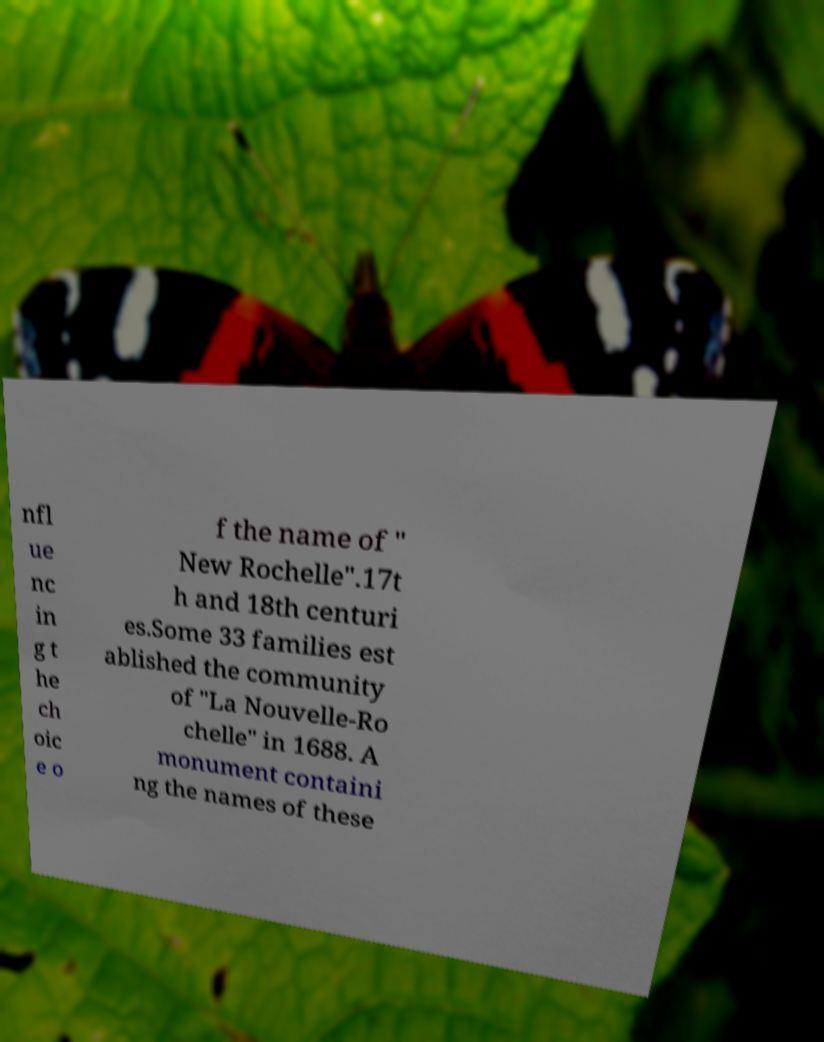Could you assist in decoding the text presented in this image and type it out clearly? nfl ue nc in g t he ch oic e o f the name of " New Rochelle".17t h and 18th centuri es.Some 33 families est ablished the community of "La Nouvelle-Ro chelle" in 1688. A monument containi ng the names of these 